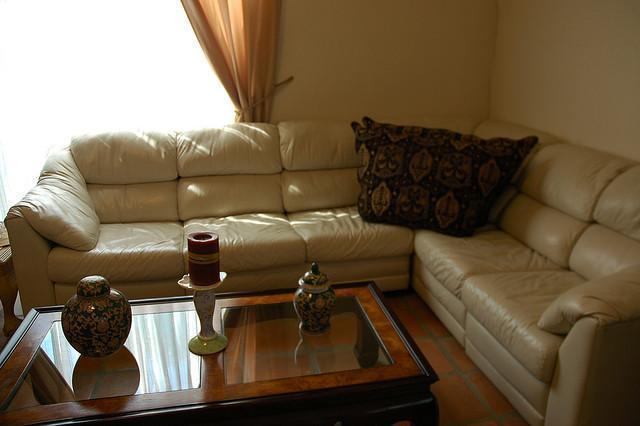Which item is most likely made from animal skin?
Answer the question by selecting the correct answer among the 4 following choices and explain your choice with a short sentence. The answer should be formatted with the following format: `Answer: choice
Rationale: rationale.`
Options: Couch, candle, floor, pillow. Answer: couch.
Rationale: It is leather 